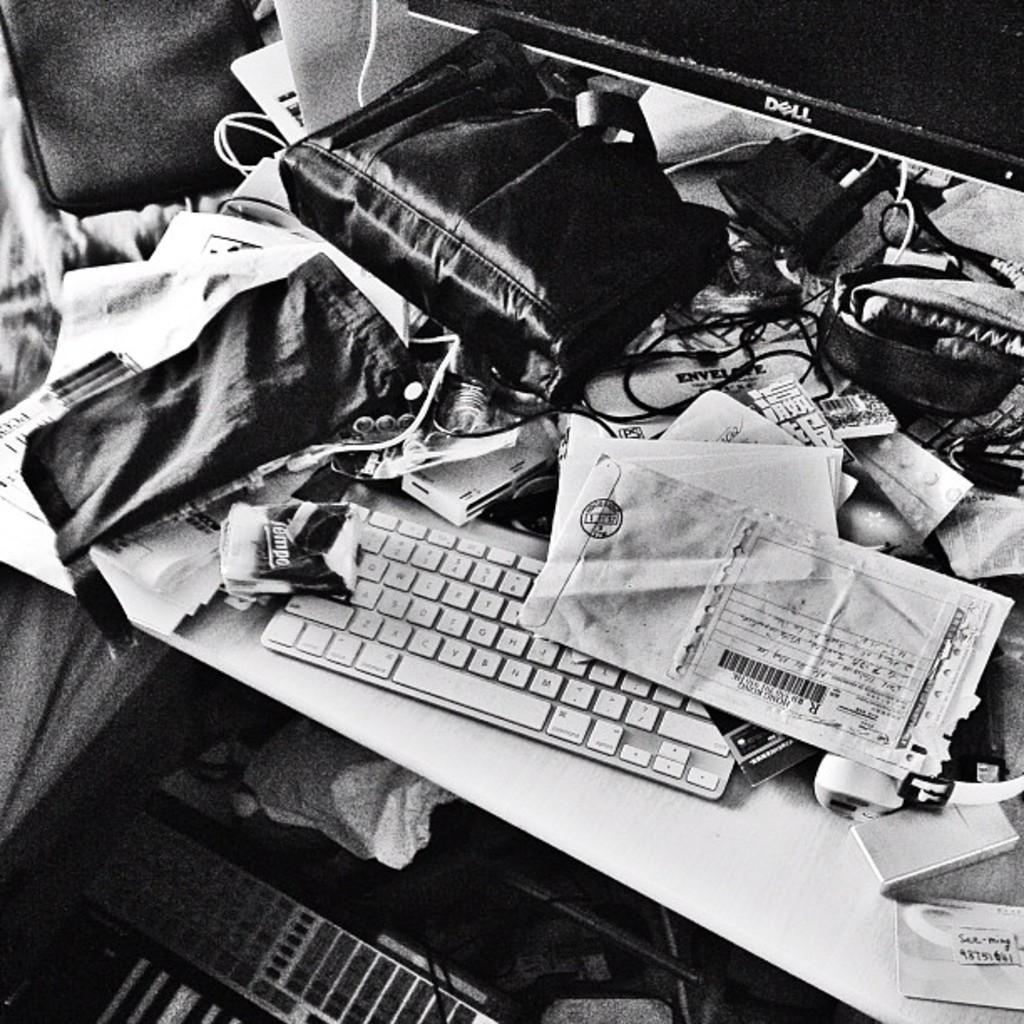Can you describe this image briefly? In this image we can see the computer, a bag, few papers and many other objects placed on the table. There is an object at the bottom of the image. 